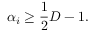<formula> <loc_0><loc_0><loc_500><loc_500>\alpha _ { i } \geq \frac { 1 } { 2 } D - 1 .</formula> 